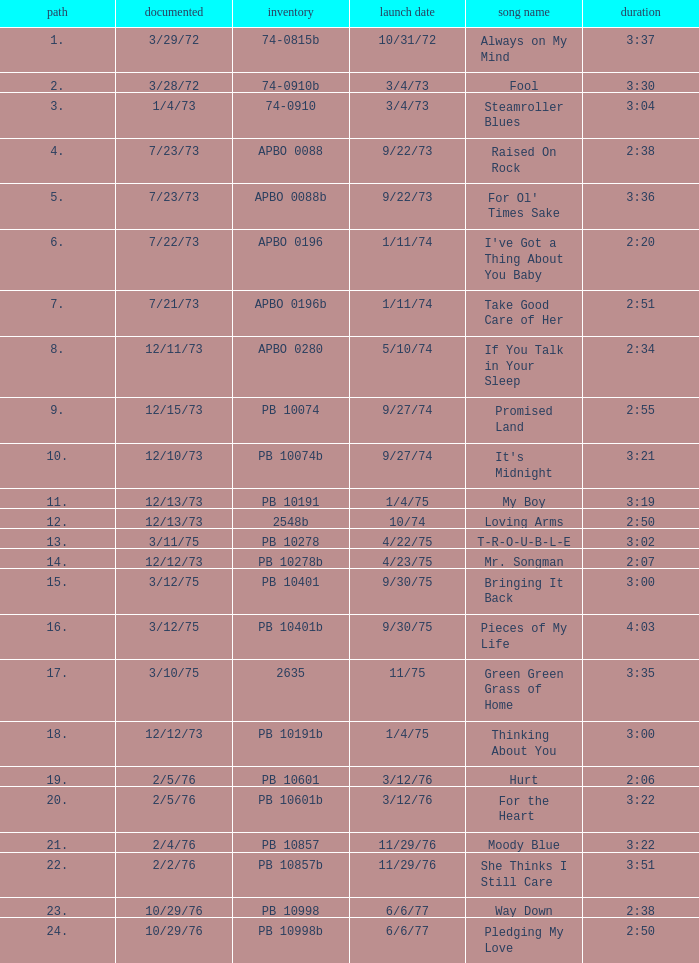Tell me the time for 6/6/77 release date and song title of way down 2:38. I'm looking to parse the entire table for insights. Could you assist me with that? {'header': ['path', 'documented', 'inventory', 'launch date', 'song name', 'duration'], 'rows': [['1.', '3/29/72', '74-0815b', '10/31/72', 'Always on My Mind', '3:37'], ['2.', '3/28/72', '74-0910b', '3/4/73', 'Fool', '3:30'], ['3.', '1/4/73', '74-0910', '3/4/73', 'Steamroller Blues', '3:04'], ['4.', '7/23/73', 'APBO 0088', '9/22/73', 'Raised On Rock', '2:38'], ['5.', '7/23/73', 'APBO 0088b', '9/22/73', "For Ol' Times Sake", '3:36'], ['6.', '7/22/73', 'APBO 0196', '1/11/74', "I've Got a Thing About You Baby", '2:20'], ['7.', '7/21/73', 'APBO 0196b', '1/11/74', 'Take Good Care of Her', '2:51'], ['8.', '12/11/73', 'APBO 0280', '5/10/74', 'If You Talk in Your Sleep', '2:34'], ['9.', '12/15/73', 'PB 10074', '9/27/74', 'Promised Land', '2:55'], ['10.', '12/10/73', 'PB 10074b', '9/27/74', "It's Midnight", '3:21'], ['11.', '12/13/73', 'PB 10191', '1/4/75', 'My Boy', '3:19'], ['12.', '12/13/73', '2548b', '10/74', 'Loving Arms', '2:50'], ['13.', '3/11/75', 'PB 10278', '4/22/75', 'T-R-O-U-B-L-E', '3:02'], ['14.', '12/12/73', 'PB 10278b', '4/23/75', 'Mr. Songman', '2:07'], ['15.', '3/12/75', 'PB 10401', '9/30/75', 'Bringing It Back', '3:00'], ['16.', '3/12/75', 'PB 10401b', '9/30/75', 'Pieces of My Life', '4:03'], ['17.', '3/10/75', '2635', '11/75', 'Green Green Grass of Home', '3:35'], ['18.', '12/12/73', 'PB 10191b', '1/4/75', 'Thinking About You', '3:00'], ['19.', '2/5/76', 'PB 10601', '3/12/76', 'Hurt', '2:06'], ['20.', '2/5/76', 'PB 10601b', '3/12/76', 'For the Heart', '3:22'], ['21.', '2/4/76', 'PB 10857', '11/29/76', 'Moody Blue', '3:22'], ['22.', '2/2/76', 'PB 10857b', '11/29/76', 'She Thinks I Still Care', '3:51'], ['23.', '10/29/76', 'PB 10998', '6/6/77', 'Way Down', '2:38'], ['24.', '10/29/76', 'PB 10998b', '6/6/77', 'Pledging My Love', '2:50']]} 